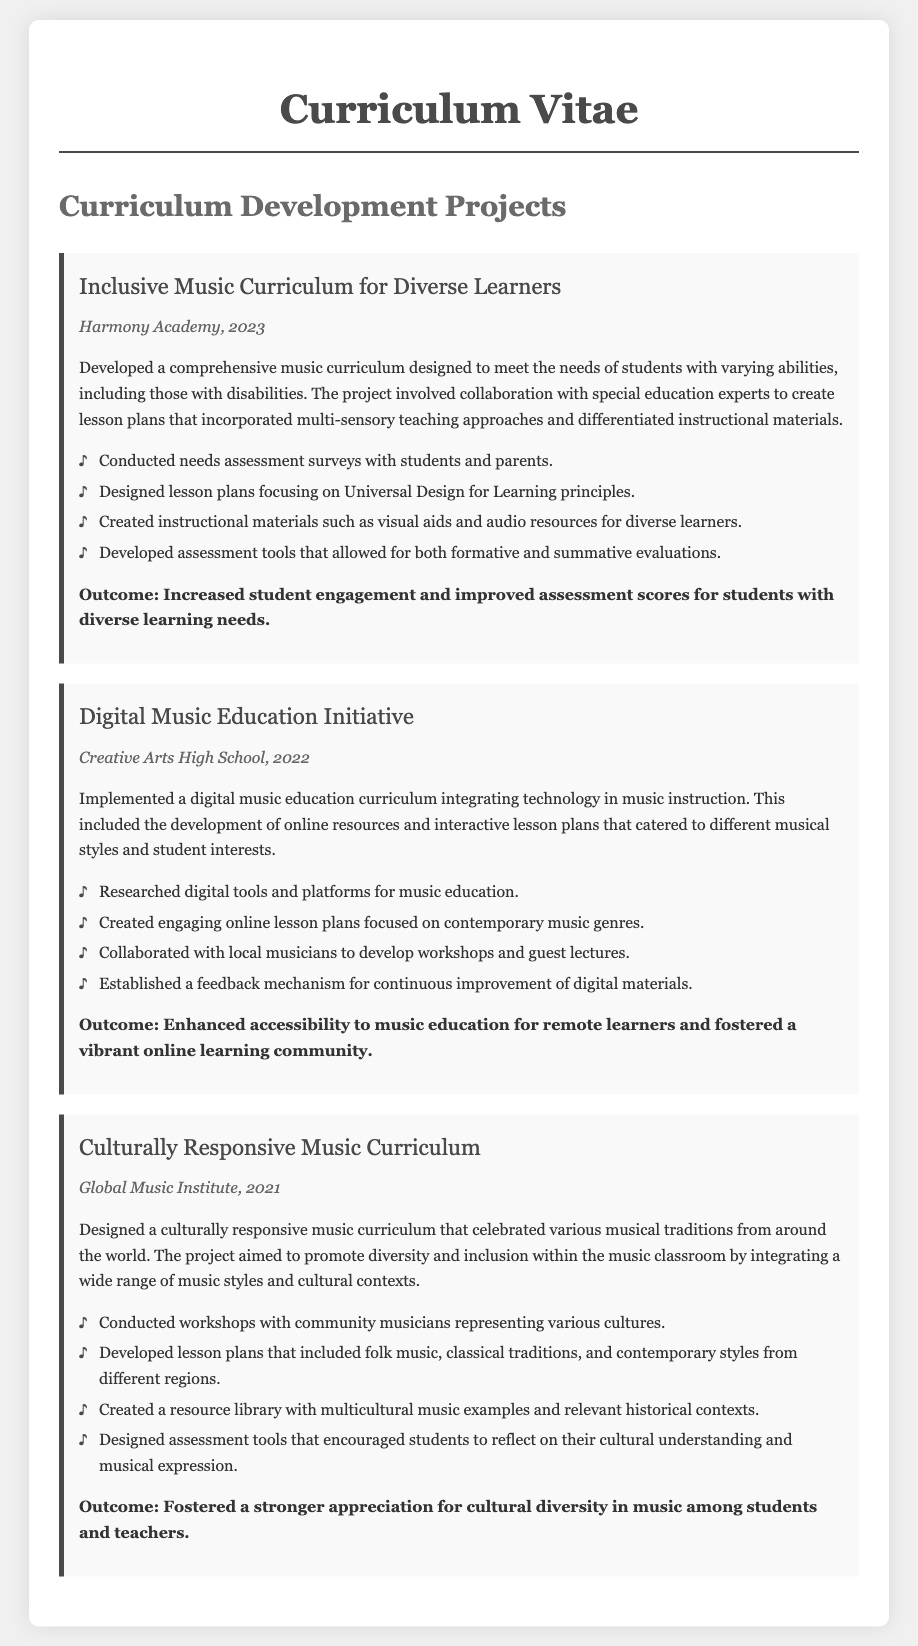what is the title of the first project? The title of the first project is mentioned at the beginning of the detailed description, which is "Inclusive Music Curriculum for Diverse Learners."
Answer: Inclusive Music Curriculum for Diverse Learners what year was the Digital Music Education Initiative implemented? The year associated with the Digital Music Education Initiative is provided in the project details section, specifically marked as 2022.
Answer: 2022 who collaborated with the curriculum development for the Inclusive Music Curriculum? The document states that collaboration took place with special education experts for the Inclusive Music Curriculum project.
Answer: special education experts what was one outcome of the Culturally Responsive Music Curriculum project? The outcomes are listed and one of them states that it fostered a stronger appreciation for cultural diversity in music.
Answer: stronger appreciation for cultural diversity how many projects are detailed in the document? The number of projects can be counted by reviewing the project sections presented in the document. There are three distinct projects listed.
Answer: three what aspect of music education was emphasized in the Digital Music Education Initiative? The emphasis of the initiative is highlighted as the integration of technology in music instruction.
Answer: technology integration what type of assessment tools were developed for the Inclusive Music Curriculum? The assessment tools created are described as allowing both formative and summative evaluations, which reflects their purpose.
Answer: formative and summative evaluations which institution implemented the Culturally Responsive Music Curriculum? The specific institution that executed the Culturally Responsive Music Curriculum is noted in the project details as Global Music Institute.
Answer: Global Music Institute 